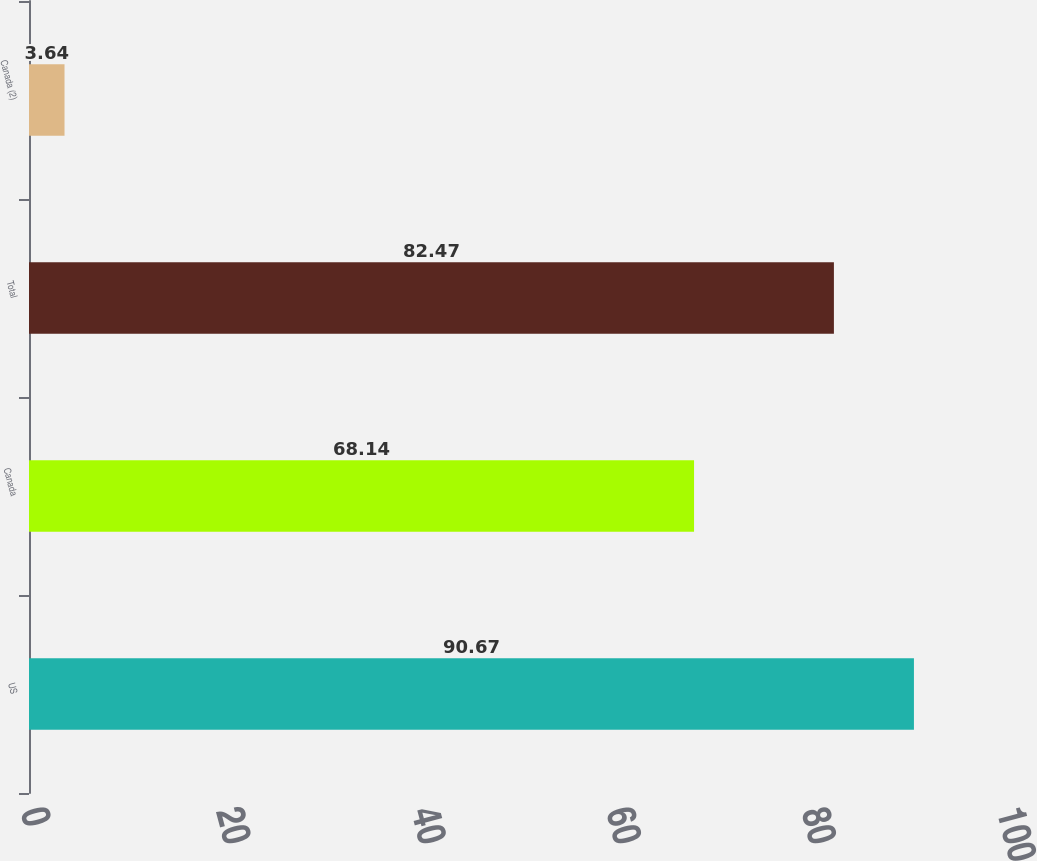<chart> <loc_0><loc_0><loc_500><loc_500><bar_chart><fcel>US<fcel>Canada<fcel>Total<fcel>Canada (2)<nl><fcel>90.67<fcel>68.14<fcel>82.47<fcel>3.64<nl></chart> 